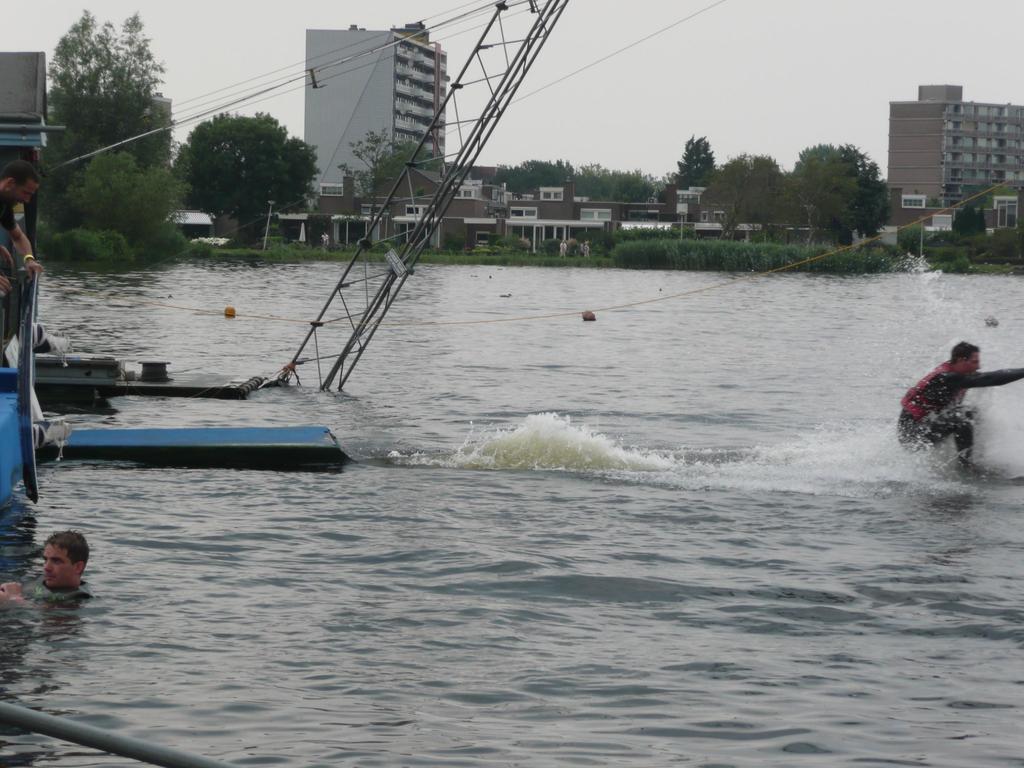Please provide a concise description of this image. In this image we can see persons in water. In the background we can see trees, buildings, planets, houses and sky. On the left side of the image person in boat. 